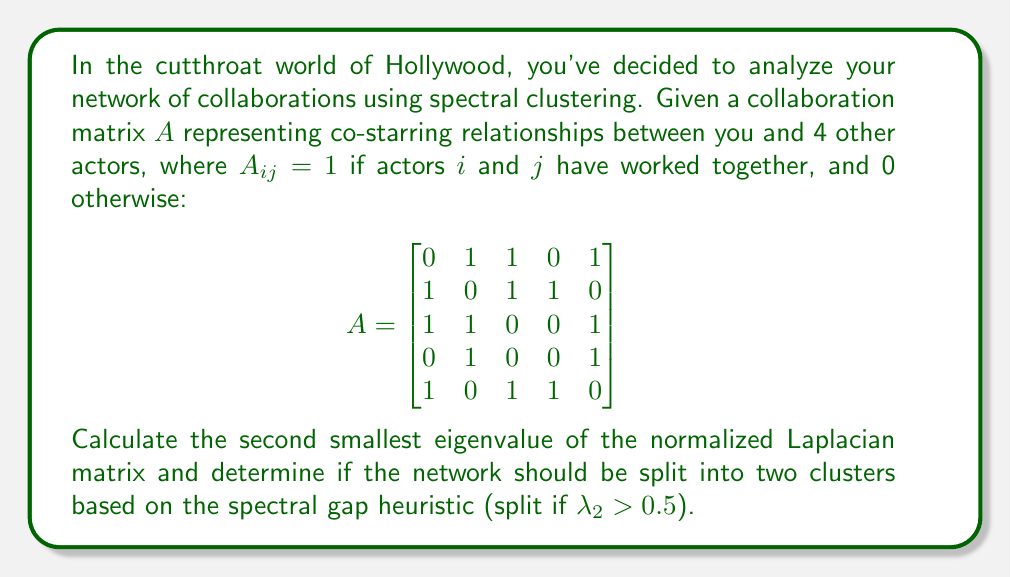Could you help me with this problem? 1. Calculate the degree matrix $D$:
   $$D = \begin{bmatrix}
   3 & 0 & 0 & 0 & 0 \\
   0 & 3 & 0 & 0 & 0 \\
   0 & 0 & 3 & 0 & 0 \\
   0 & 0 & 0 & 2 & 0 \\
   0 & 0 & 0 & 0 & 3
   \end{bmatrix}$$

2. Calculate the normalized Laplacian $L_{\text{norm}} = I - D^{-1/2}AD^{-1/2}$:
   $$L_{\text{norm}} = I - \begin{bmatrix}
   0 & \frac{1}{\sqrt{9}} & \frac{1}{\sqrt{9}} & 0 & \frac{1}{\sqrt{9}} \\
   \frac{1}{\sqrt{9}} & 0 & \frac{1}{\sqrt{9}} & \frac{1}{\sqrt{6}} & 0 \\
   \frac{1}{\sqrt{9}} & \frac{1}{\sqrt{9}} & 0 & 0 & \frac{1}{\sqrt{9}} \\
   0 & \frac{1}{\sqrt{6}} & 0 & 0 & \frac{1}{\sqrt{6}} \\
   \frac{1}{\sqrt{9}} & 0 & \frac{1}{\sqrt{9}} & \frac{1}{\sqrt{6}} & 0
   \end{bmatrix}$$

3. Calculate the eigenvalues of $L_{\text{norm}}$ (using a computer algebra system):
   $\lambda_1 = 0$
   $\lambda_2 \approx 0.3820$
   $\lambda_3 \approx 0.5858$
   $\lambda_4 \approx 1.0000$
   $\lambda_5 \approx 1.5322$

4. The second smallest eigenvalue is $\lambda_2 \approx 0.3820$.

5. Compare $\lambda_2$ to the threshold of 0.5:
   $0.3820 < 0.5$

6. Since $\lambda_2 < 0.5$, the spectral gap heuristic suggests not splitting the network into two clusters.
Answer: $\lambda_2 \approx 0.3820$; Do not split 